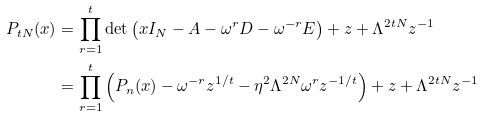<formula> <loc_0><loc_0><loc_500><loc_500>P _ { t N } ( x ) & = \prod _ { r = 1 } ^ { t } \det \left ( x I _ { N } - A - \omega ^ { r } D - \omega ^ { - r } E \right ) + z + \Lambda ^ { 2 t N } z ^ { - 1 } \\ & = \prod _ { r = 1 } ^ { t } \left ( P _ { n } ( x ) - \omega ^ { - r } z ^ { 1 / t } - \eta ^ { 2 } \Lambda ^ { 2 N } \omega ^ { r } z ^ { - 1 / t } \right ) + z + \Lambda ^ { 2 t N } z ^ { - 1 }</formula> 